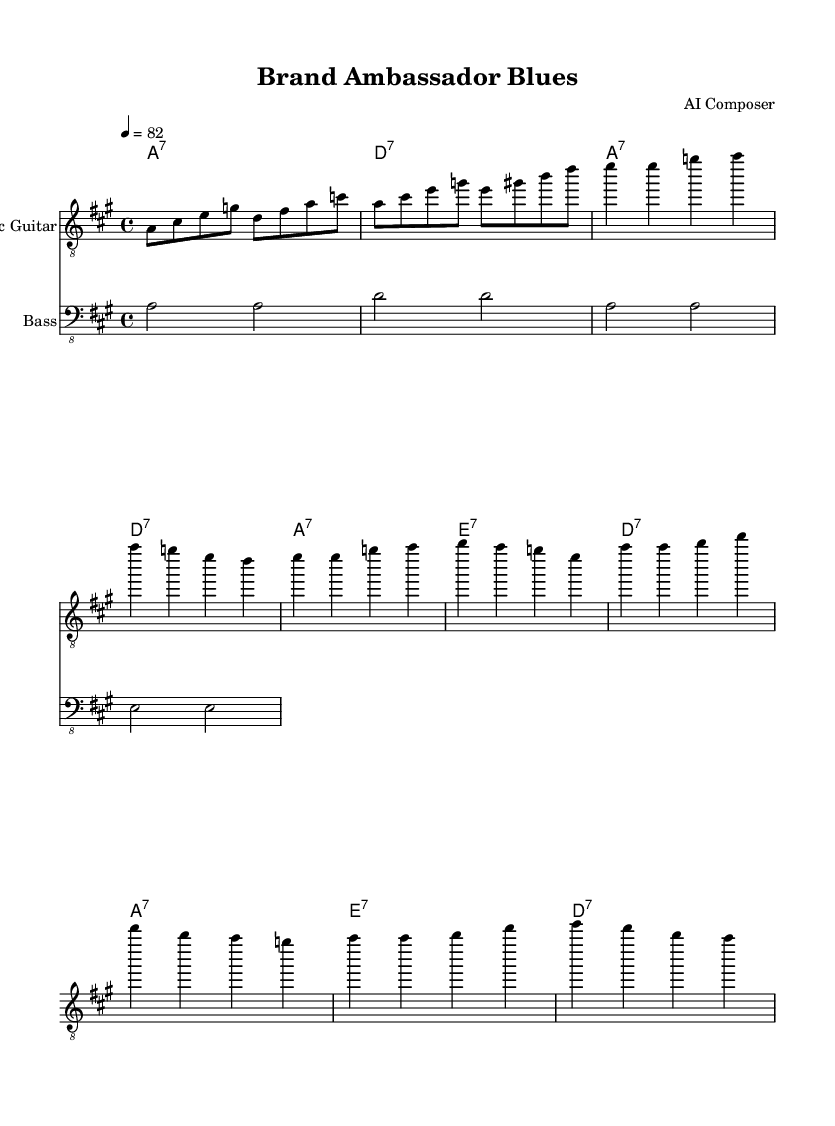What is the key signature of this music? The key signature is A major, which has three sharps (F#, C#, and G#).
Answer: A major What is the time signature of the piece? The time signature is represented as 4/4, which indicates four beats per measure.
Answer: 4/4 What is the tempo marking in this piece? The tempo marking is given as quarter note equals 82 beats per minute.
Answer: 82 How many measures are in the verse section? The verse section consists of four measures, indicated by the four lines of melody in that section.
Answer: Four What is the structure of the song? The structure of the song includes an intro, a verse, and a chorus, which can be inferred from the distinct sections highlighted in the music.
Answer: Intro, Verse, Chorus What type of chords are predominantly used in this piece? The chords are seventh chords, indicated by the use of the notation with a "7" symbol next to the chord names.
Answer: Seventh chords What genre does this piece represent? The piece represents the Electric Blues genre, which can be identified by the style indicated in the title and the characteristic layout of the score.
Answer: Electric Blues 